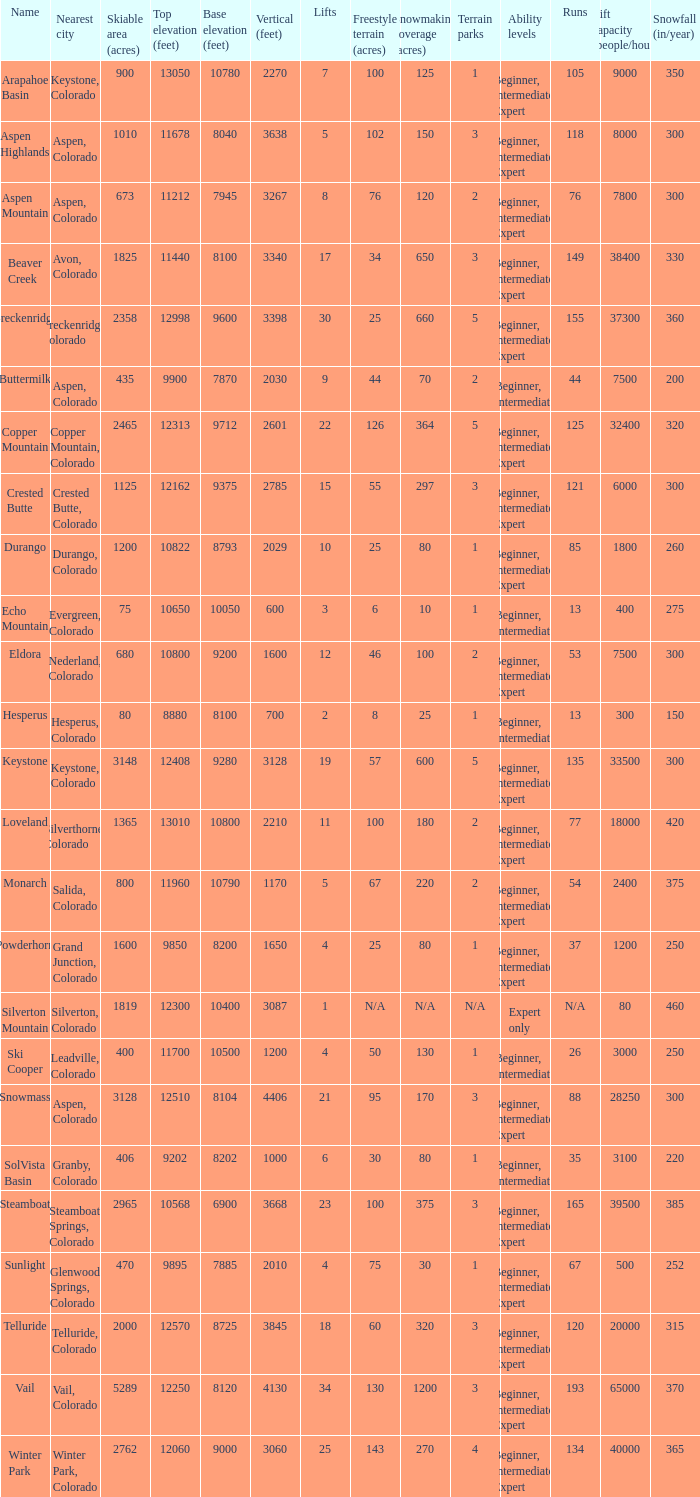What is the snowfall for ski resort Snowmass? 300.0. 